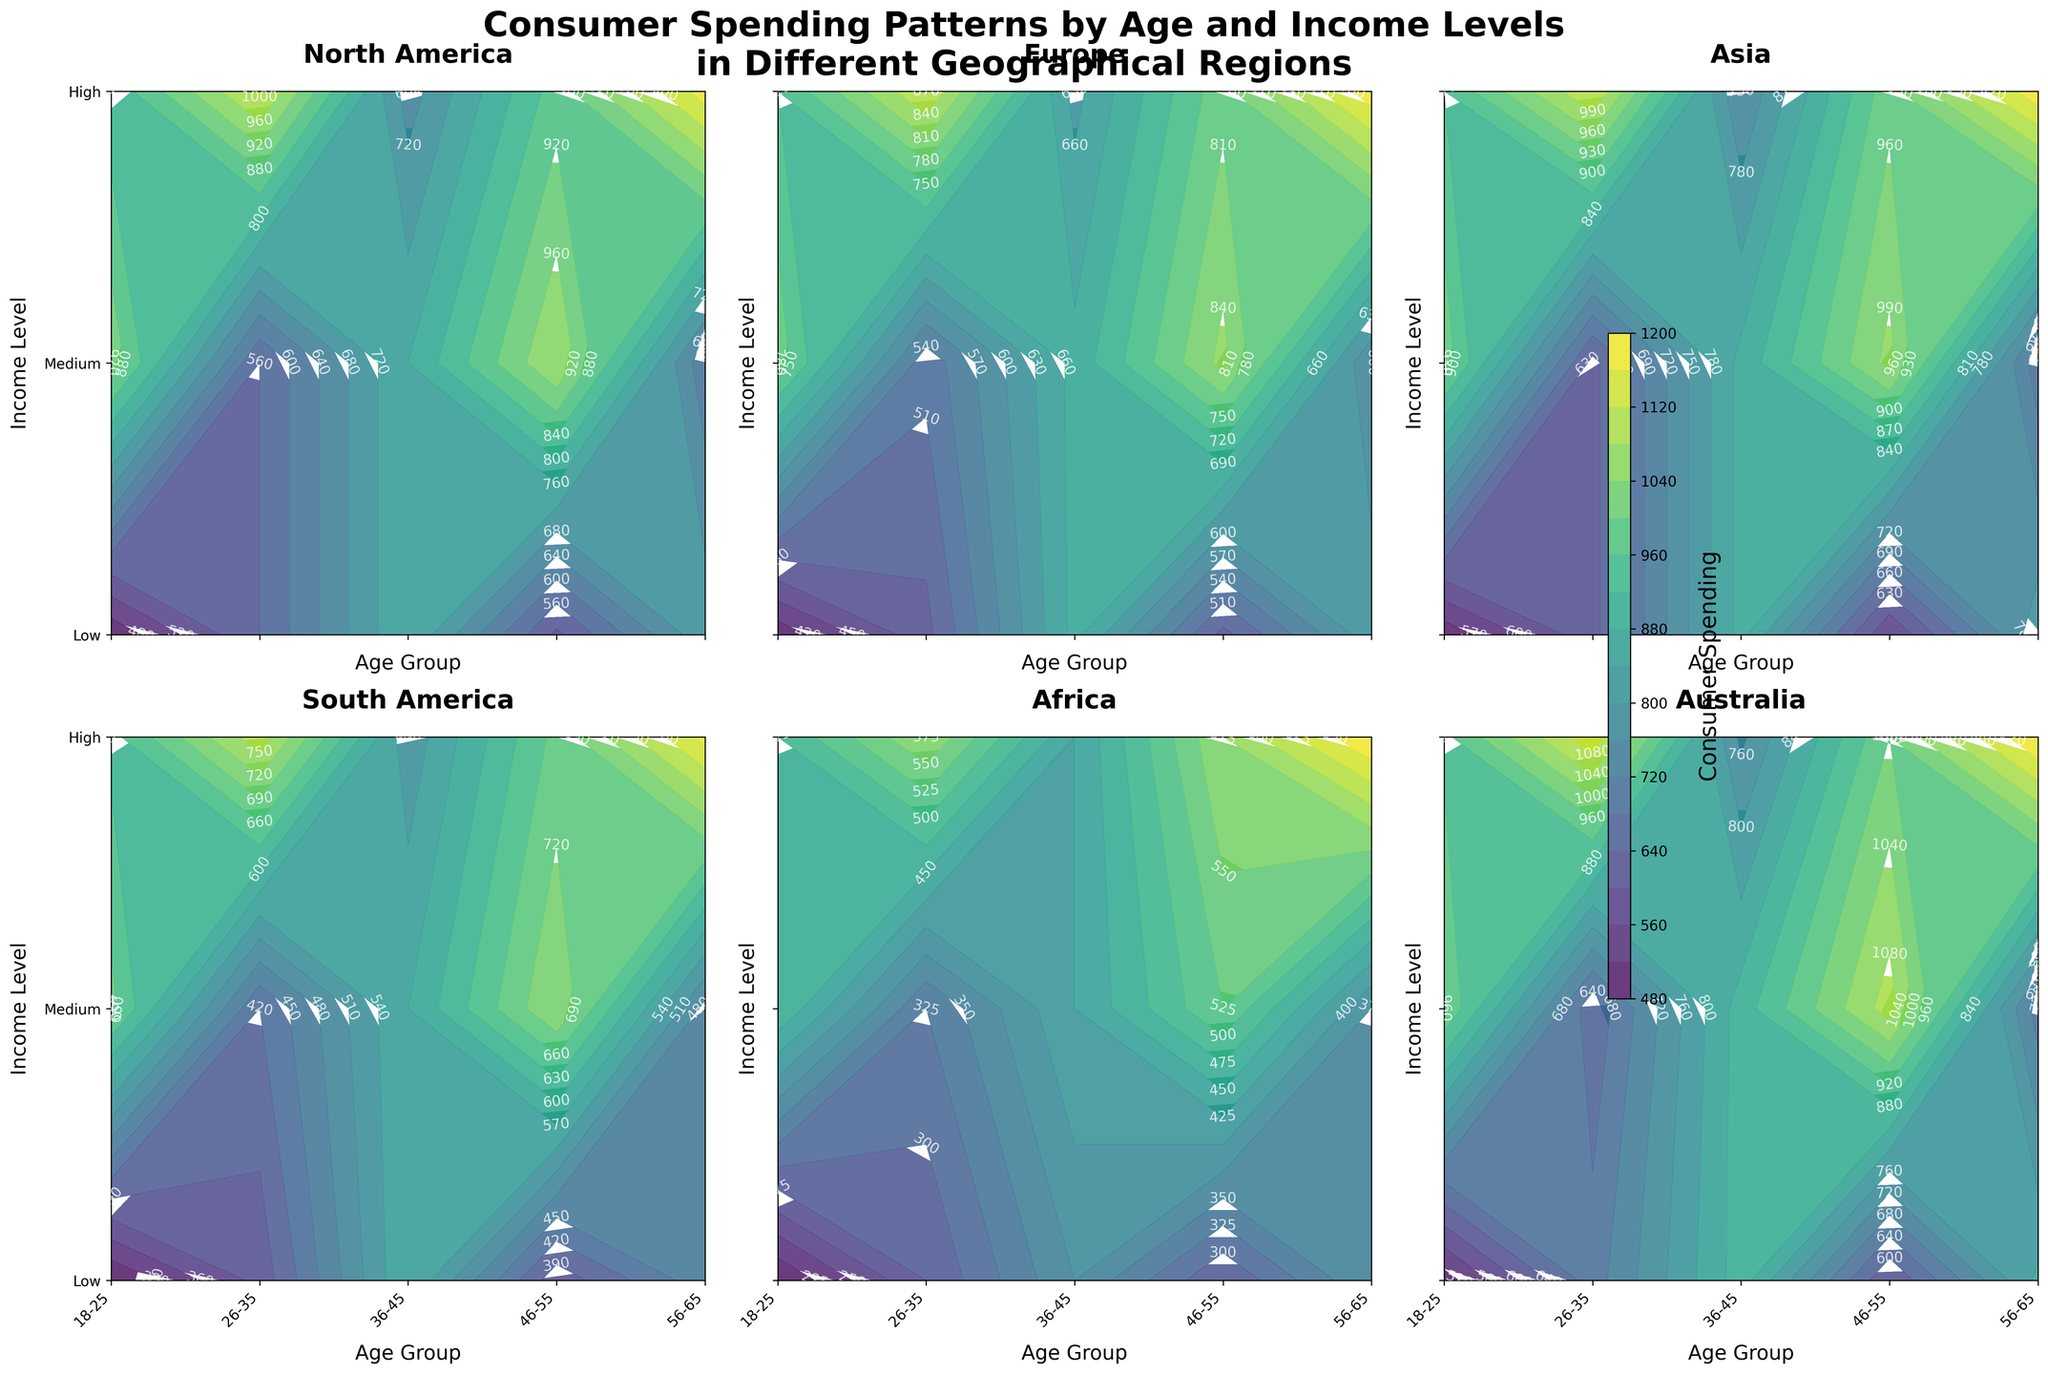What is the title of the figure? The title of the figure is usually found at the top and summarizes the content of the plot. From the provided code, it is "Consumer Spending Patterns by Age and Income Levels in Different Geographical Regions".
Answer: Consumer Spending Patterns by Age and Income Levels in Different Geographical Regions Which age group and income level have the highest consumer spending in North America? To determine the highest consumer spending, look at the contour plot for North America and locate the point with the highest value. According to the data, this occurs in the age group 56-65 with a high-income level.
Answer: 56-65, High What are the x and y-axis labels for each subplot? The x and y-axis labels indicate what is being compared in each subplot. From the provided code, the labels are "Age Group" for the x-axis and "Income Level" for the y-axis.
Answer: Age Group, Income Level In which region do 36-45-year-olds with medium income show the highest consumer spending? Look at the contour levels for the medium-income bracket for the age group 36-45 across all regions. The highest value for this cohort is visible in the plot for North America.
Answer: North America Compare consumer spending in the 26-35 age group with high income in Europe and Asia. Which region has higher spending? To compare, check the contour levels for the 26-35 group with high income in Europe and Asia. According to the data, Europe has 800 and Asia has 950, making Asia higher.
Answer: Asia In South America, which income level for age group 18-25 shows the least consumer spending? Examine the South America plot and identify which contour corresponds to the lowest spending for the 18-25 age group across different income levels. The lowest spending is seen in the low-income level.
Answer: Low For the age group 46-55 in Australia, which income level sees the most increase in consumer spending compared to the previous age group 36-45? Identify the consumer spending values for each income level for 46-55 and compare them with 36-45 in Australia. The high-income level shows the most significant increase.
Answer: High What is the color scheme used for the contour plots? The color scheme used in the contour plots is provided by the 'viridis' colormap, which ranges from purple to yellow. Examine the gradient from the plot for reference.
Answer: viridis Which region has the most evenly distributed consumer spending across all age and income levels? To find the most evenly distributed spending, look for the region where the contour lines are most equally spaced and levels transition smoothly. Europe shows a more even distribution compared to others.
Answer: Europe How does consumer spending for the low-income level change as the age group increases in Africa? Observe the contour plot for Africa and trace the changes in consumer spending for the low-income level across age groups. There's a gradual increase in spending from 200 to 450.
Answer: It increases 